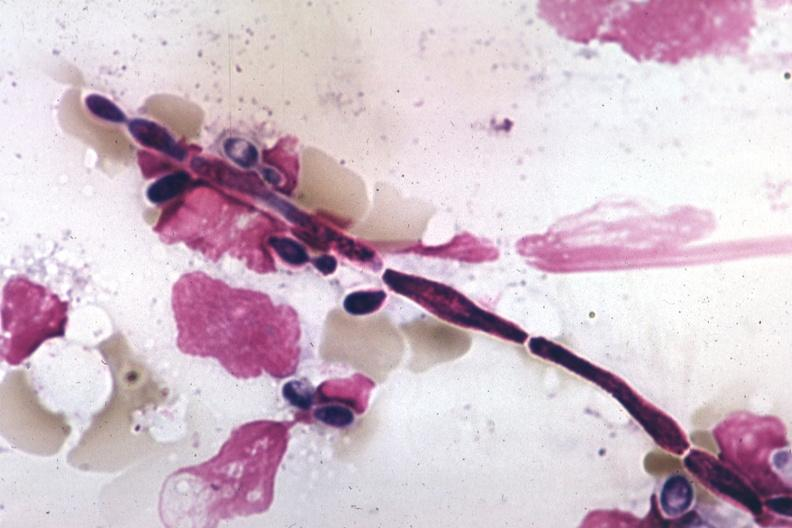what is present?
Answer the question using a single word or phrase. Blood 